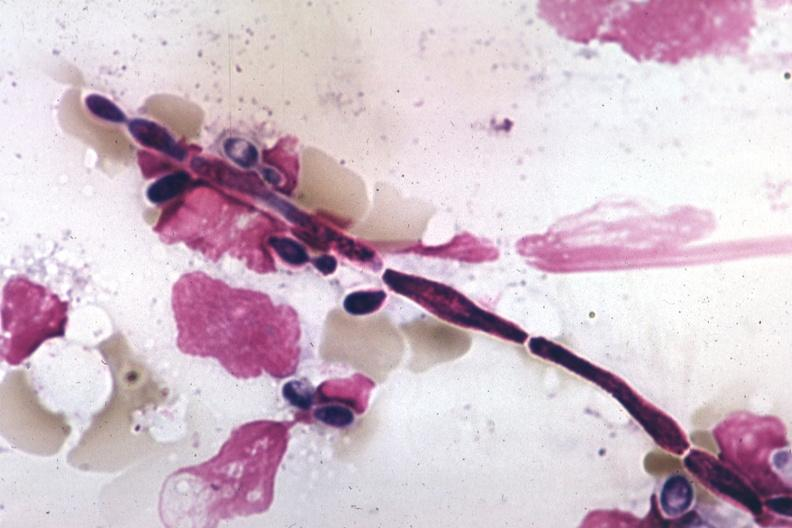what is present?
Answer the question using a single word or phrase. Blood 